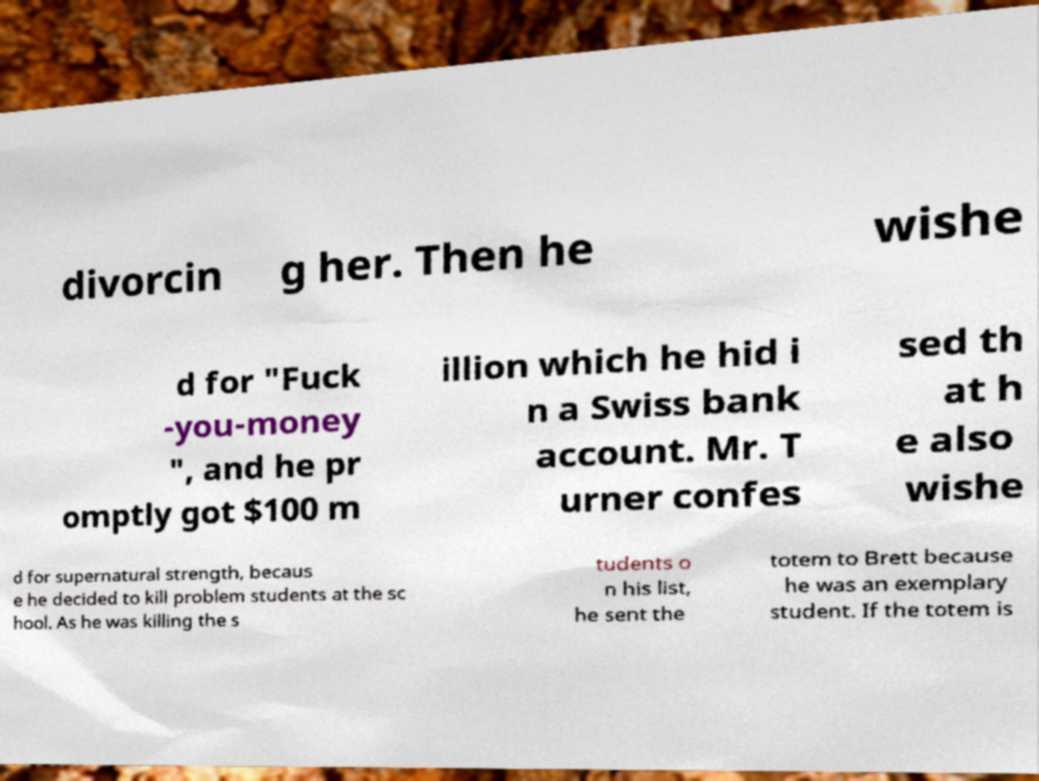Please read and relay the text visible in this image. What does it say? divorcin g her. Then he wishe d for "Fuck -you-money ", and he pr omptly got $100 m illion which he hid i n a Swiss bank account. Mr. T urner confes sed th at h e also wishe d for supernatural strength, becaus e he decided to kill problem students at the sc hool. As he was killing the s tudents o n his list, he sent the totem to Brett because he was an exemplary student. If the totem is 